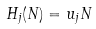<formula> <loc_0><loc_0><loc_500><loc_500>H _ { j } ( N ) = u _ { j } N</formula> 